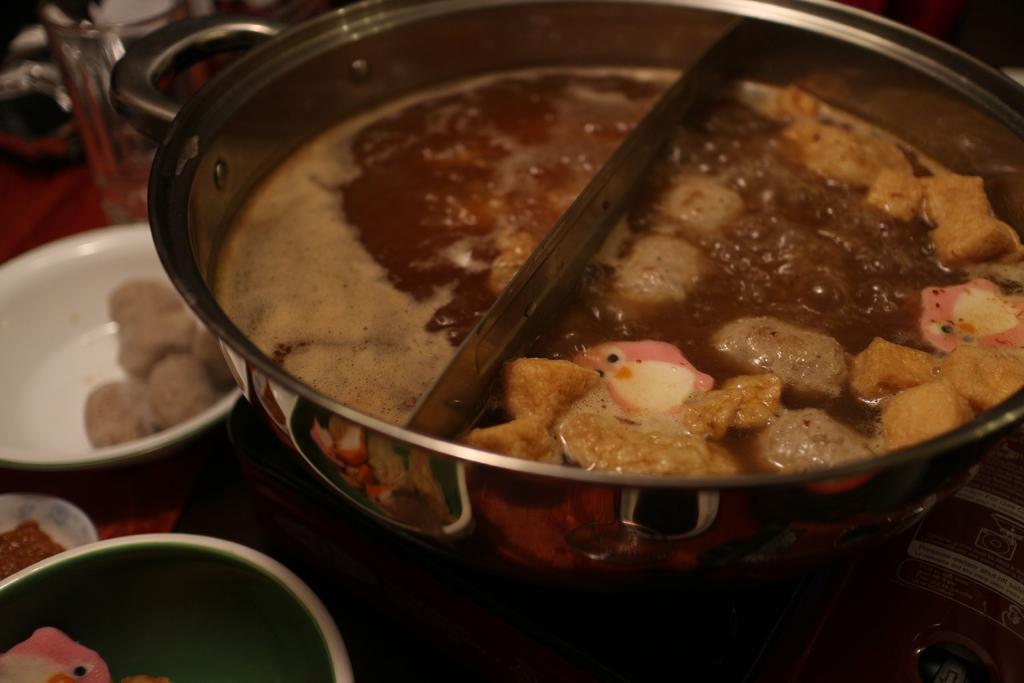How would you summarize this image in a sentence or two? In the picture I can see food items in a bowl and some other objects. In the background I can see some other utensils on wooden surface. 